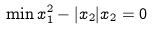<formula> <loc_0><loc_0><loc_500><loc_500>\min x _ { 1 } ^ { 2 } - | x _ { 2 } | x _ { 2 } = 0</formula> 